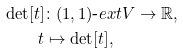Convert formula to latex. <formula><loc_0><loc_0><loc_500><loc_500>\det [ t ] & \colon ( 1 , 1 ) \text {-} e x t V \rightarrow \mathbb { R } , \\ t & \mapsto \det [ t ] ,</formula> 